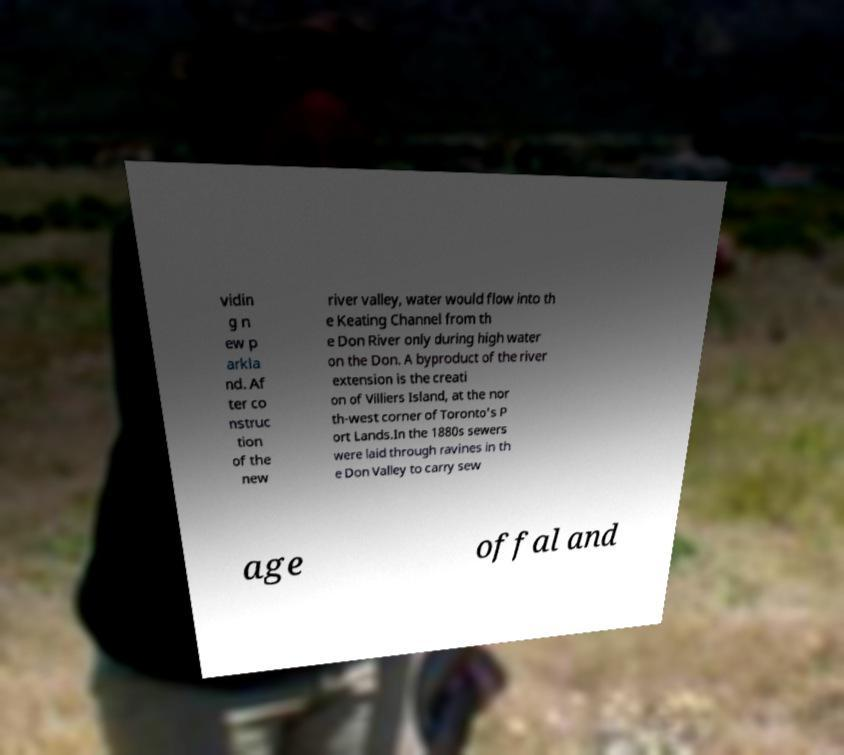Please identify and transcribe the text found in this image. vidin g n ew p arkla nd. Af ter co nstruc tion of the new river valley, water would flow into th e Keating Channel from th e Don River only during high water on the Don. A byproduct of the river extension is the creati on of Villiers Island, at the nor th-west corner of Toronto's P ort Lands.In the 1880s sewers were laid through ravines in th e Don Valley to carry sew age offal and 